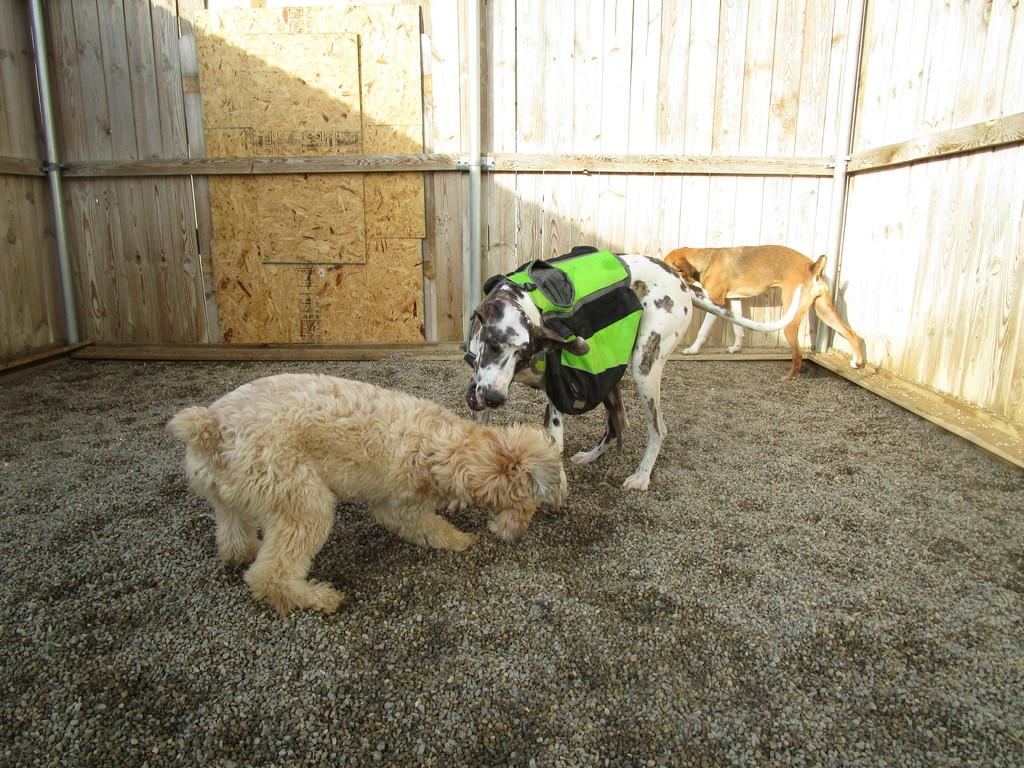What type of animals are in the image? There is a group of dogs in the image. Where are the dogs located? The dogs are on the ground. What is the color of the ground? The ground is brown in color. What can be seen in the background of the image? There is a wooden wall in the background of the image. What type of boats are visible in the image? There are no boats present in the image; it features a group of dogs on the ground with a wooden wall in the background. 